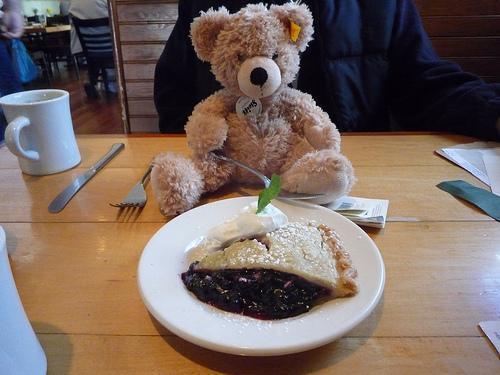How many bears are shown?
Give a very brief answer. 1. 